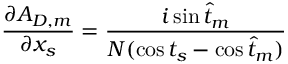Convert formula to latex. <formula><loc_0><loc_0><loc_500><loc_500>{ \frac { \partial A _ { D , m } } { \partial x _ { s } } } = { \frac { i \sin \hat { t } _ { m } } { N ( \cos t _ { s } - \cos \hat { t } _ { m } ) } }</formula> 